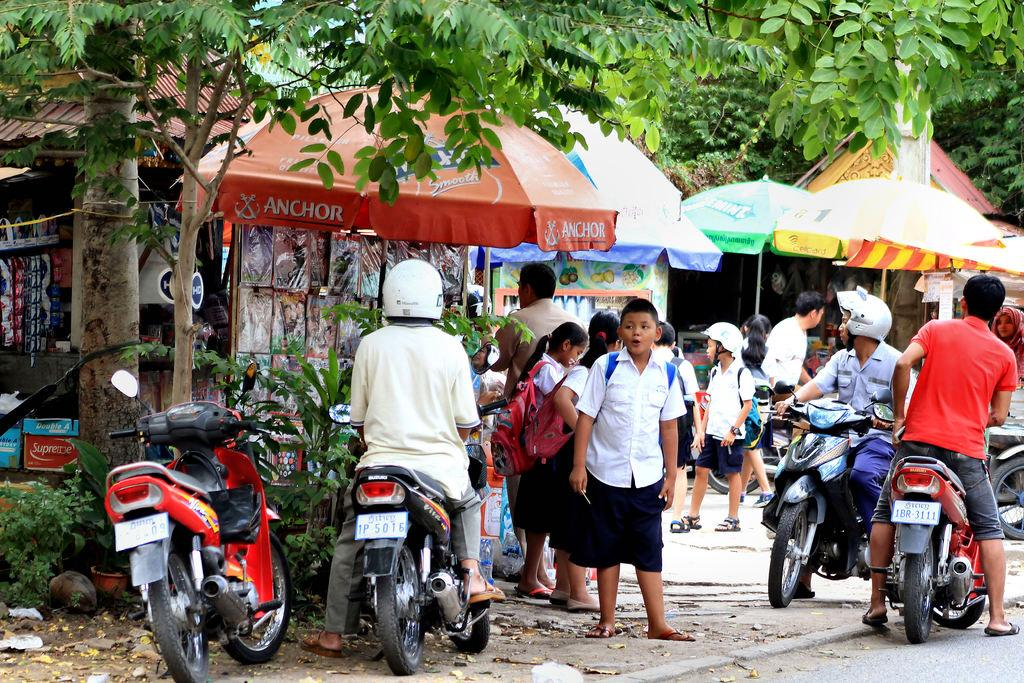How many people are in the image? There is a group of people in the image, but the exact number is not specified. What are the people in the image doing? Some people are standing, while others are sitting on a bike. What structures can be seen in the image? There are tents in the image. What type of natural environment is visible in the image? There are trees in the image. What type of mint is growing near the tents in the image? There is no mention of mint in the image, so it cannot be determined if any mint is present. 